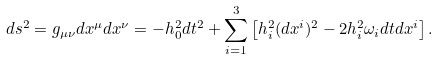<formula> <loc_0><loc_0><loc_500><loc_500>d s ^ { 2 } = g _ { \mu \nu } d x ^ { \mu } d x ^ { \nu } = - h _ { 0 } ^ { 2 } d t ^ { 2 } + \sum _ { i = 1 } ^ { 3 } \left [ h _ { i } ^ { 2 } ( d x ^ { i } ) ^ { 2 } - 2 h _ { i } ^ { 2 } \omega _ { i } d t d x ^ { i } \right ] .</formula> 